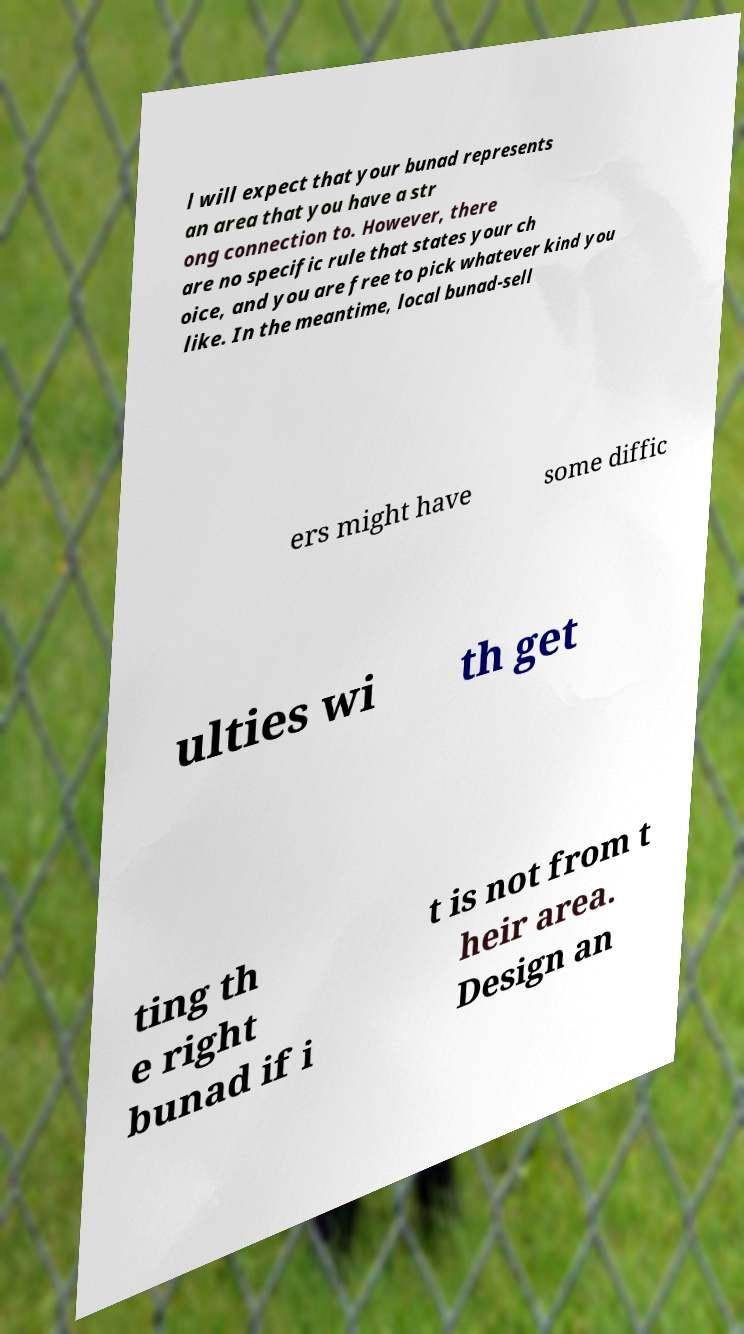Can you read and provide the text displayed in the image?This photo seems to have some interesting text. Can you extract and type it out for me? l will expect that your bunad represents an area that you have a str ong connection to. However, there are no specific rule that states your ch oice, and you are free to pick whatever kind you like. In the meantime, local bunad-sell ers might have some diffic ulties wi th get ting th e right bunad if i t is not from t heir area. Design an 